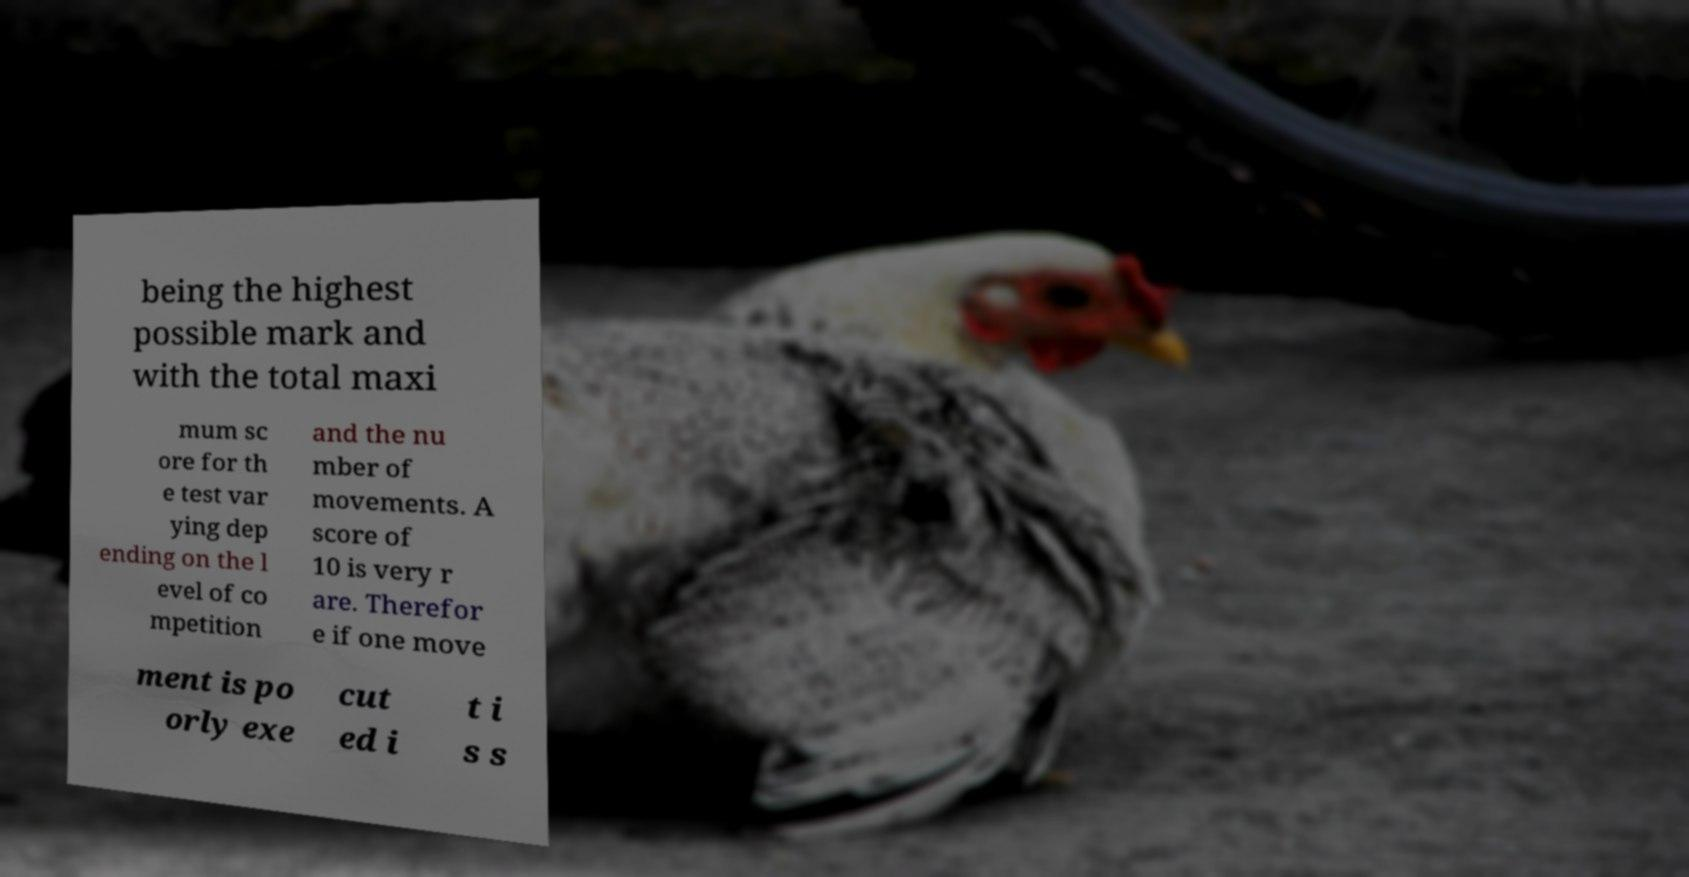Please identify and transcribe the text found in this image. being the highest possible mark and with the total maxi mum sc ore for th e test var ying dep ending on the l evel of co mpetition and the nu mber of movements. A score of 10 is very r are. Therefor e if one move ment is po orly exe cut ed i t i s s 